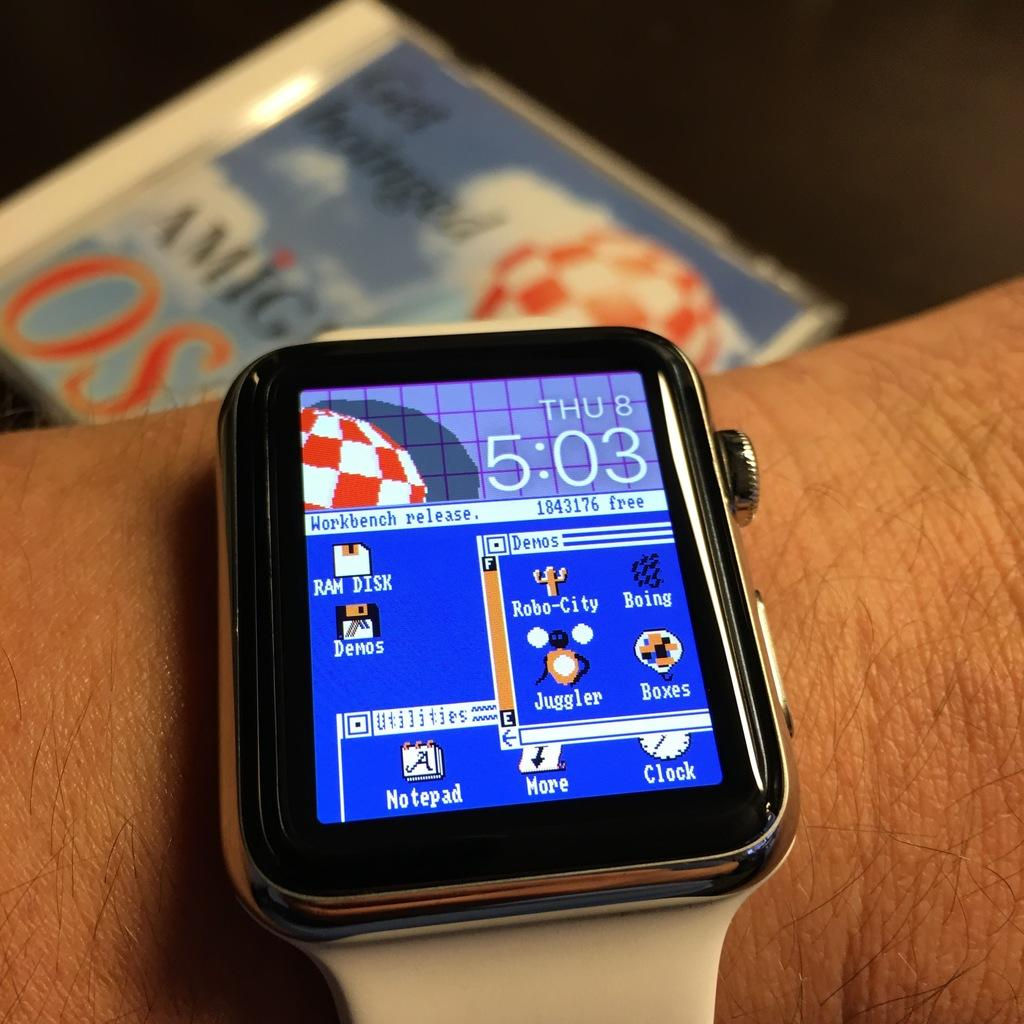<image>
Give a short and clear explanation of the subsequent image. The face of a smartwatch that reads workbench on it 